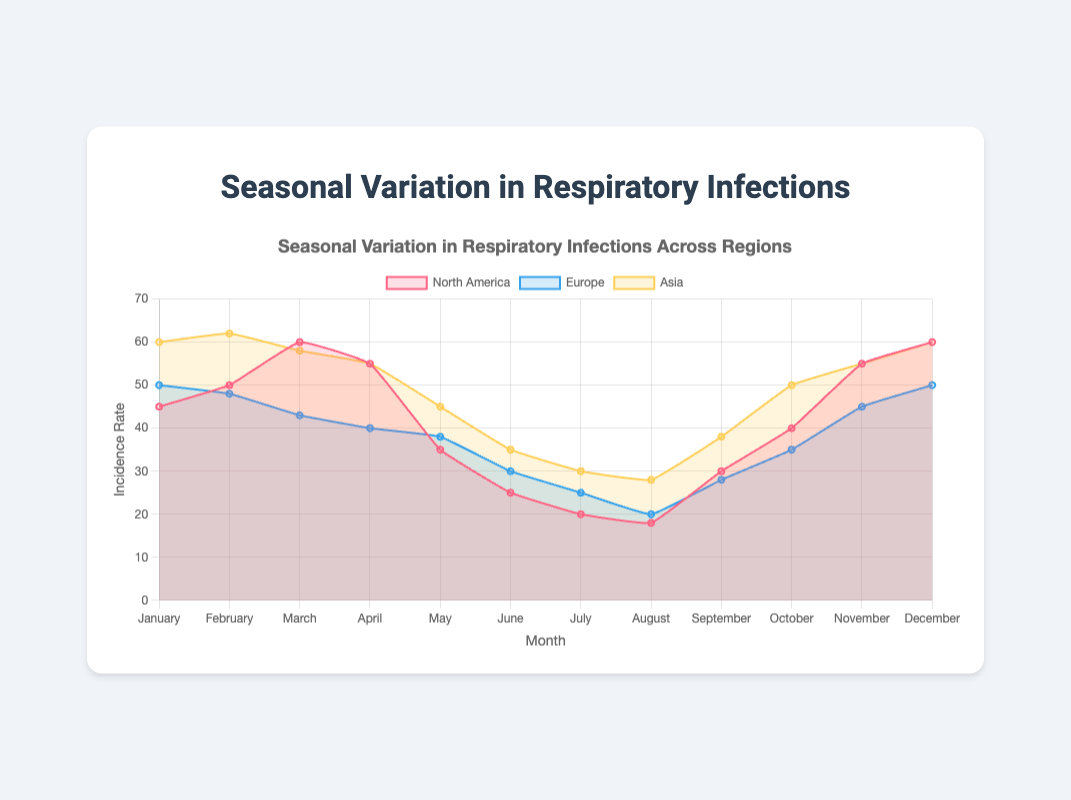What is the highest incidence of respiratory infections in North America? The highest incidence in North America occurs in March and December, both reaching 60. This value can be seen on the y-axis where the peak for North America intersects.
Answer: 60 In which month does Europe have the lowest incidence of respiratory infections? By observing the line representing Europe, the lowest point should be in August, where the incidence rate is 20.
Answer: August Compare the incidence rate of respiratory infections in Asia and North America in July. Which is higher? Check the incidence values for July in both regions. Asia has an incidence of 30, while North America has an incidence of 20. Asia's rate is higher.
Answer: Asia In which month does Asia have the highest incidence rate? Looking at the line for Asia, the highest peaks occur in January, February, and December with the incidence rate of 60.
Answer: January, February, December What is the average incidence rate in Europe from June to August? Sum the incidence rates for June (30), July (25), and August (20). Then, divide the total by 3, which equals (30 + 25 + 20) / 3 = 75 / 3 = 25.
Answer: 25 Which regions have an incidence rate of 50 in December? From the December data points, both North America and Europe have an incidence rate of 50.
Answer: North America, Europe How does the incidence rate change from January to June in Asia? Observe the trend line for Asia from January to June. The incidence starts at 60 in January, increases slightly to 62 in February, then gradually declines to 58, 55, 45, and finally 35 in June.
Answer: It decreases What is the combined incidence rate of respiratory infections for all regions in April? Sum the incidence rates for April in North America (55), Europe (40), and Asia (55). This gives 55 + 40 + 55 = 150.
Answer: 150 Which region shows a decreasing trend from January to May? By following the lines, Europe shows a continuously decreasing trend from January (50) to May (38).
Answer: Europe What is the most common incidence rate across all regions in November? Observing the lines for November, both North America and Europe share an incidence rate of 55, which is also common in Asia.
Answer: 55 